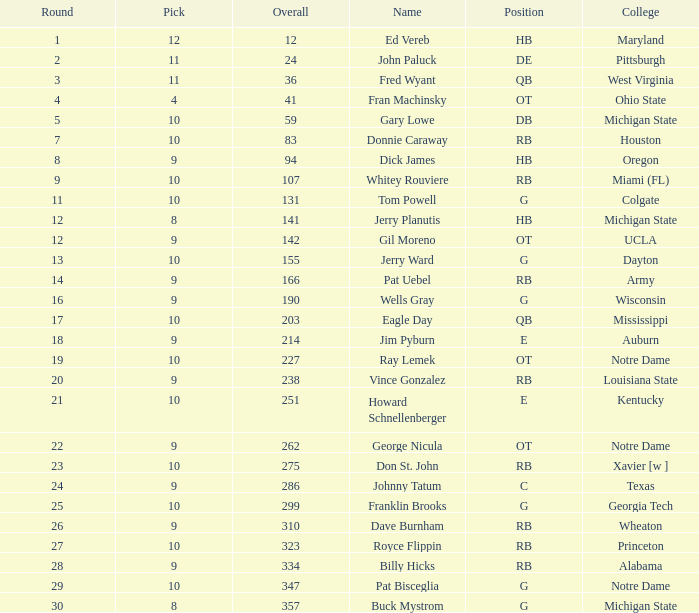What is the overall pick number for a draft pick smaller than 9, named buck mystrom from Michigan State college? 357.0. 